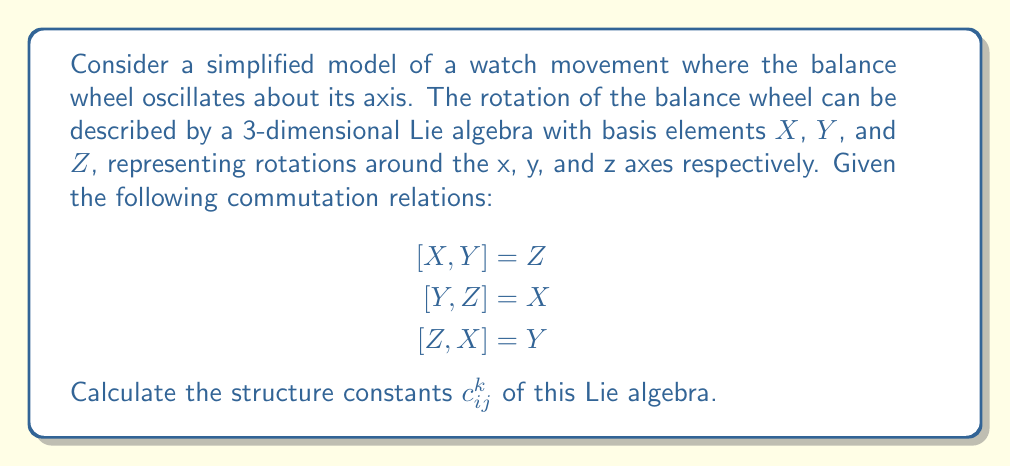Give your solution to this math problem. To solve this problem, we'll follow these steps:

1) Recall that the structure constants $c_{ij}^k$ are defined by the equation:

   $$[X_i, X_j] = \sum_k c_{ij}^k X_k$$

   where $X_i$, $X_j$, and $X_k$ are basis elements of the Lie algebra.

2) In our case, we have three basis elements: $X$, $Y$, and $Z$. We can identify these as:
   
   $X_1 = X$, $X_2 = Y$, $X_3 = Z$

3) Now, let's analyze each commutation relation:

   a) $[X,Y] = Z$ implies $[X_1, X_2] = X_3$
      This means $c_{12}^3 = 1$, and $c_{12}^1 = c_{12}^2 = 0$

   b) $[Y,Z] = X$ implies $[X_2, X_3] = X_1$
      This means $c_{23}^1 = 1$, and $c_{23}^2 = c_{23}^3 = 0$

   c) $[Z,X] = Y$ implies $[X_3, X_1] = X_2$
      This means $c_{31}^2 = 1$, and $c_{31}^1 = c_{31}^3 = 0$

4) Note that the structure constants are antisymmetric in the lower indices:
   
   $c_{ij}^k = -c_{ji}^k$

   This gives us:
   $c_{21}^3 = -1$, $c_{32}^1 = -1$, $c_{13}^2 = -1$

5) All other structure constants are zero.

This Lie algebra is actually isomorphic to $\mathfrak{so}(3)$, the Lie algebra of the 3D rotation group, which is indeed relevant to the mechanics of a watch movement.
Answer: The non-zero structure constants are:

$c_{12}^3 = 1$, $c_{23}^1 = 1$, $c_{31}^2 = 1$
$c_{21}^3 = -1$, $c_{32}^1 = -1$, $c_{13}^2 = -1$

All other $c_{ij}^k = 0$. 